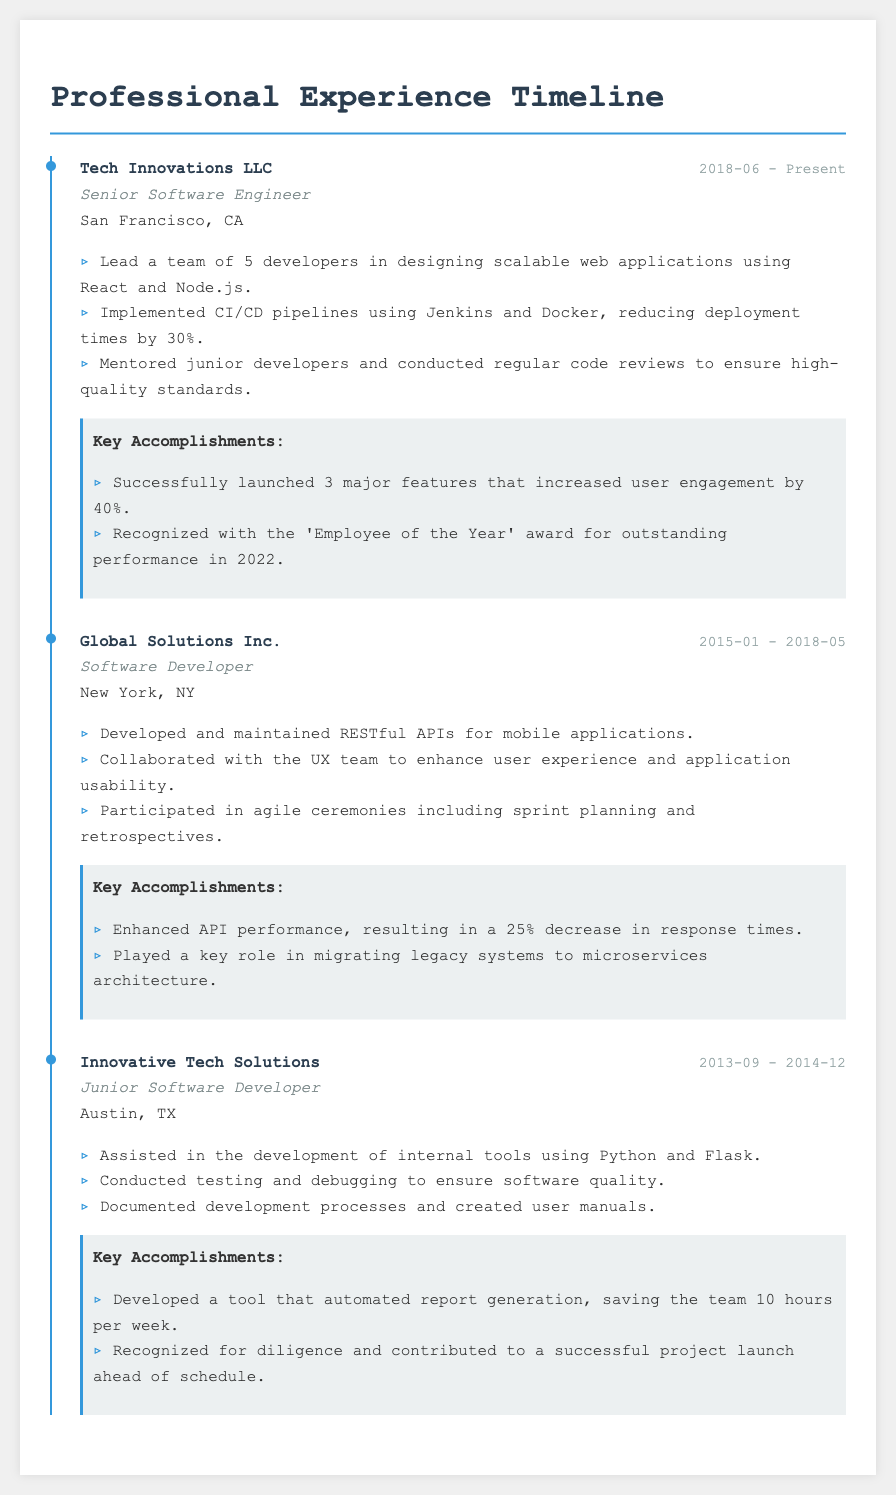What is the current role held at Tech Innovations LLC? The role held is stated in the job section under Tech Innovations LLC, which is Senior Software Engineer.
Answer: Senior Software Engineer What was the duration of employment at Global Solutions Inc.? The dates provided in the job section for Global Solutions Inc. indicate the start and end of employment, which is from January 2015 to May 2018.
Answer: 2015-01 - 2018-05 How many developers did the individual lead at Tech Innovations LLC? The job responsibilities mention leading a team, specifying that the individual led a team of 5 developers at Tech Innovations LLC.
Answer: 5 What significant feature launch increased user engagement by 40%? The key accomplishments list mentions three major features launched that resulted in increased user engagement, specifically stating the increase by 40%.
Answer: 3 major features What technology was primarily used for developing internal tools as a Junior Software Developer? The role as a Junior Software Developer at Innovative Tech Solutions includes the technologies used, which are Python and Flask.
Answer: Python and Flask What achievement resulted in the 'Employee of the Year' award? The key accomplishments at Tech Innovations LLC specify being recognized with the 'Employee of the Year' award for outstanding performance, hence this award is linked to overall performance.
Answer: outstanding performance Which city was Global Solutions Inc. located in? The job section indicates the location for Global Solutions Inc., which is New York, NY.
Answer: New York, NY What was a notable improvement in API performance at Global Solutions Inc.? The key accomplishments describe enhancing API performance, specifically noting a 25% decrease in response times.
Answer: 25% decrease What role did the individual start their career in? The job section shows that the individual began as a Junior Software Developer at Innovative Tech Solutions.
Answer: Junior Software Developer 